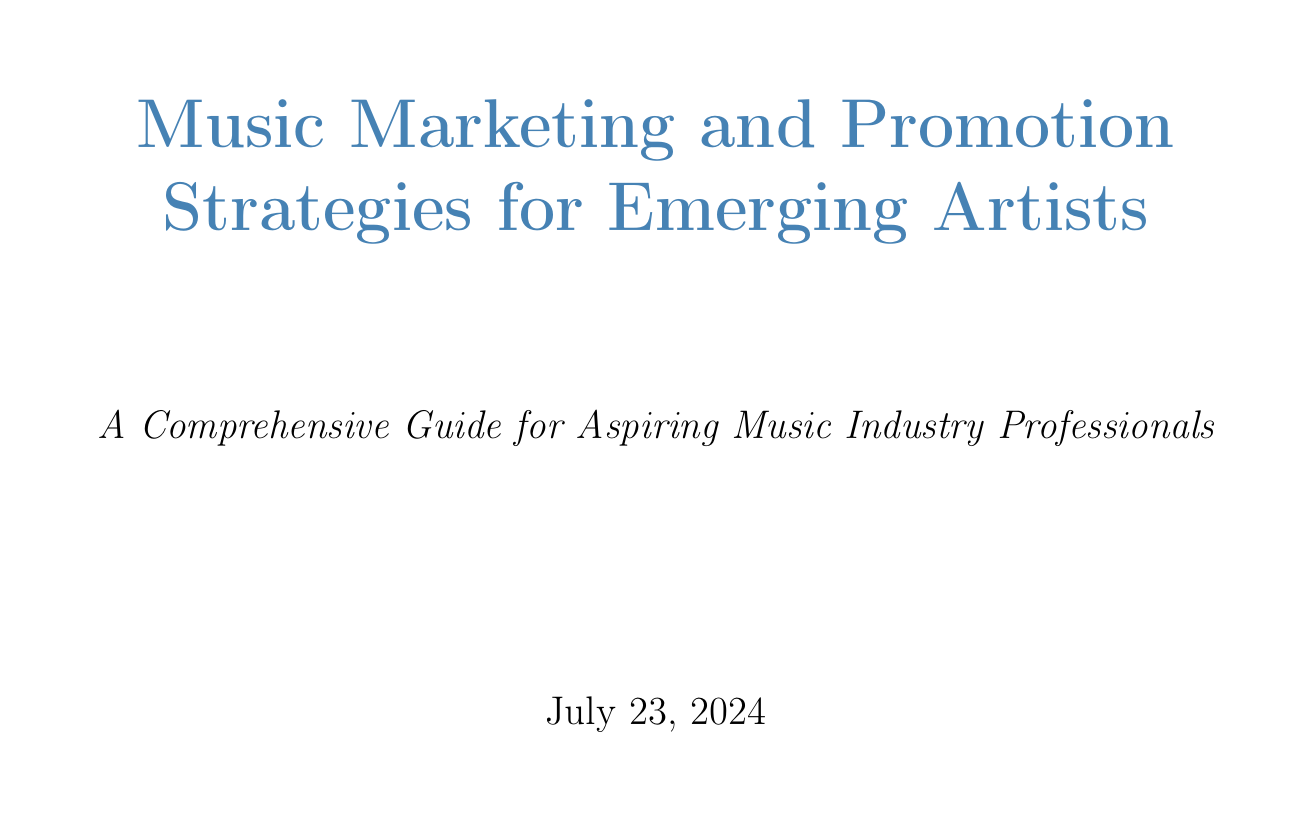what is the title of the manual? The title of the manual is included in the document title section, which shows the complete title.
Answer: Music Marketing and Promotion Strategies for Emerging Artists which social media platforms are recommended for maximum impact? The recommended platforms for social media management are listed in the "Choosing the Right Platforms" section.
Answer: Instagram, TikTok, and Twitter what is the 80/20 rule in content creation? The 80/20 rule is mentioned as a guideline for the type of content to post in the "Content Creation and Scheduling" section.
Answer: 80% engaging content, 20% promotional material name one type of event to attend for networking. The "Industry Events and Conferences" section gives examples of events helpful for networking.
Answer: SXSW what is a key component that should be included in a press kit? Essential components of a press kit are outlined in the corresponding section, specifying what to include.
Answer: Compelling bio what is a suggested tool for scheduling social media posts? A recommended scheduling tool is mentioned in the "Content Creation and Scheduling" section.
Answer: Hootsuite how should a biography begin according to the manual? Guidance on crafting an effective bio includes the suggested structure for a biography in the relevant section.
Answer: Start with a hook which music distribution service is recommended for tracking performance? The manual suggests comparing different services in the "Choosing a Distributor" section.
Answer: DistroKid how can collaborations benefit an artist? The section on "Collaborations and Partnerships" discusses the advantages of collaborations for artists.
Answer: Expand network and reach new audiences 